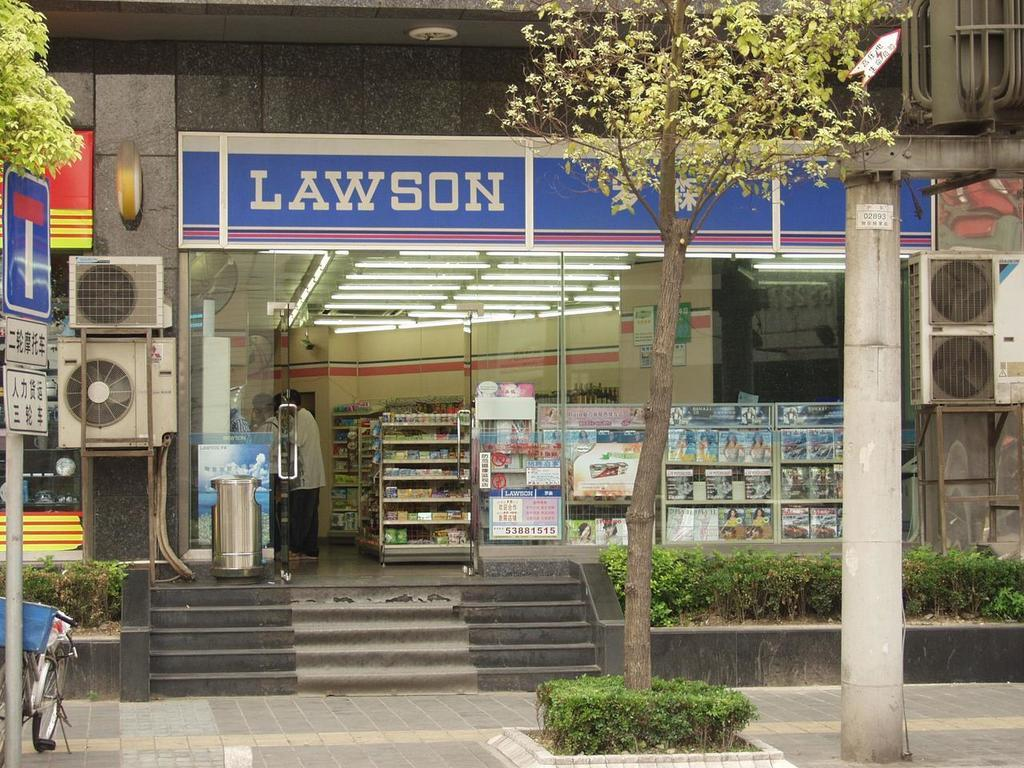Provide a one-sentence caption for the provided image. A storefront with stairs leading up to it, named Lawson. 